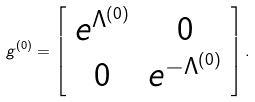Convert formula to latex. <formula><loc_0><loc_0><loc_500><loc_500>g ^ { ( 0 ) } = \left [ \begin{array} { c c } e ^ { \Lambda ^ { ( 0 ) } } & 0 \\ 0 & e ^ { - \Lambda ^ { ( 0 ) } } \end{array} \right ] .</formula> 